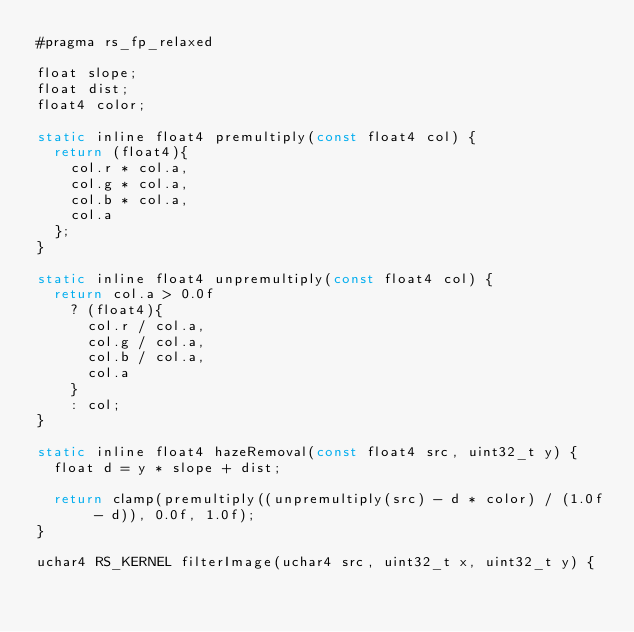Convert code to text. <code><loc_0><loc_0><loc_500><loc_500><_Rust_>#pragma rs_fp_relaxed

float slope;
float dist;
float4 color;

static inline float4 premultiply(const float4 col) {
  return (float4){
    col.r * col.a,
    col.g * col.a,
    col.b * col.a,
    col.a
  };
}

static inline float4 unpremultiply(const float4 col) {
  return col.a > 0.0f
    ? (float4){
      col.r / col.a,
      col.g / col.a,
      col.b / col.a,
      col.a
    }
    : col;
}

static inline float4 hazeRemoval(const float4 src, uint32_t y) {
  float d = y * slope + dist;

  return clamp(premultiply((unpremultiply(src) - d * color) / (1.0f - d)), 0.0f, 1.0f);
}

uchar4 RS_KERNEL filterImage(uchar4 src, uint32_t x, uint32_t y) {</code> 